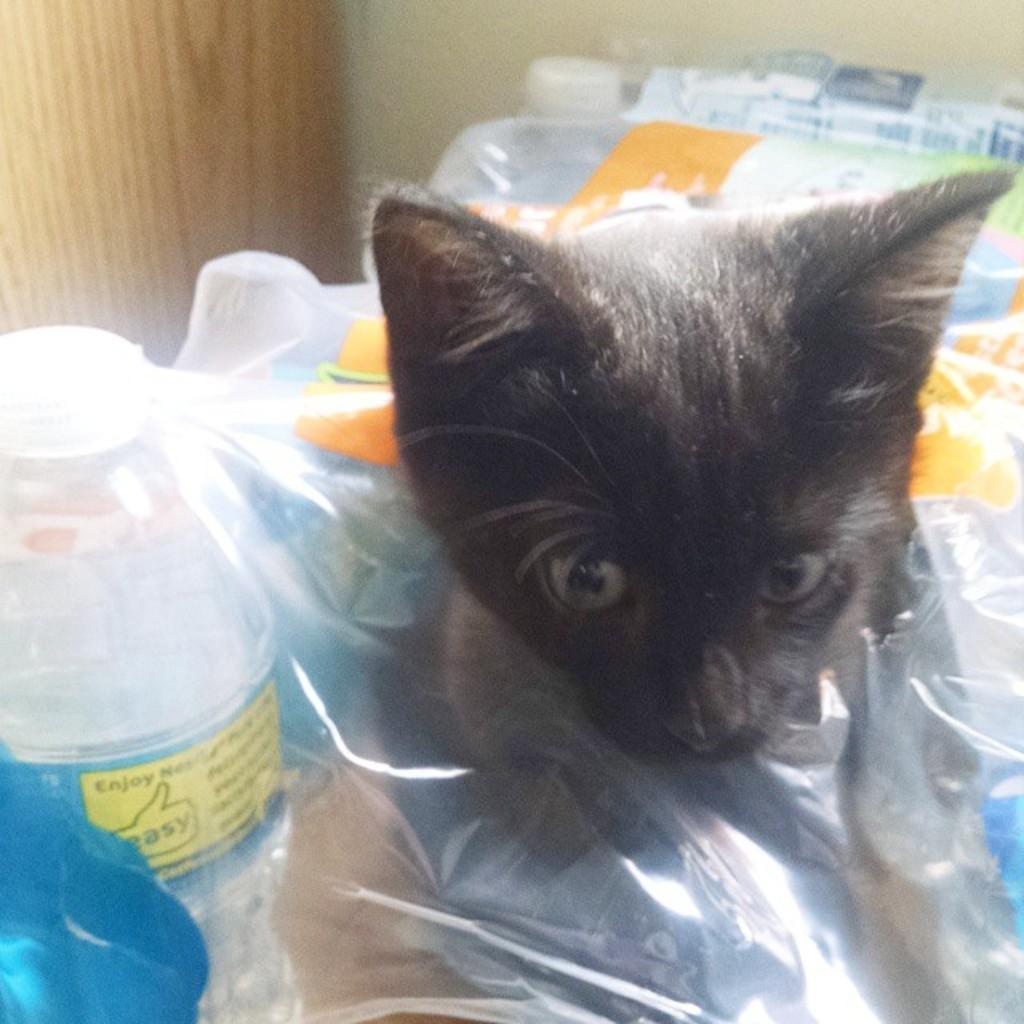Describe this image in one or two sentences. In this picture we can see a cat, plastic covers, bottles, wooden object and in the background we can see the wall. 